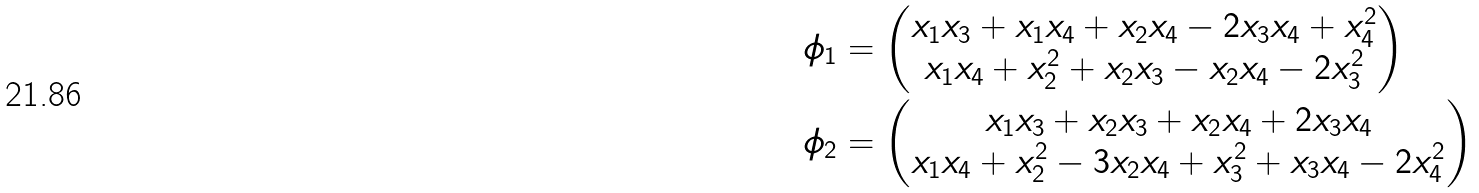Convert formula to latex. <formula><loc_0><loc_0><loc_500><loc_500>\phi _ { 1 } & = \begin{pmatrix} x _ { 1 } x _ { 3 } + x _ { 1 } x _ { 4 } + x _ { 2 } x _ { 4 } - 2 x _ { 3 } x _ { 4 } + x _ { 4 } ^ { 2 } \\ x _ { 1 } x _ { 4 } + x _ { 2 } ^ { 2 } + x _ { 2 } x _ { 3 } - x _ { 2 } x _ { 4 } - 2 x _ { 3 } ^ { 2 } \end{pmatrix} \\ \phi _ { 2 } & = \begin{pmatrix} x _ { 1 } x _ { 3 } + x _ { 2 } x _ { 3 } + x _ { 2 } x _ { 4 } + 2 x _ { 3 } x _ { 4 } \\ x _ { 1 } x _ { 4 } + x _ { 2 } ^ { 2 } - 3 x _ { 2 } x _ { 4 } + x _ { 3 } ^ { 2 } + x _ { 3 } x _ { 4 } - 2 x _ { 4 } ^ { 2 } \end{pmatrix}</formula> 